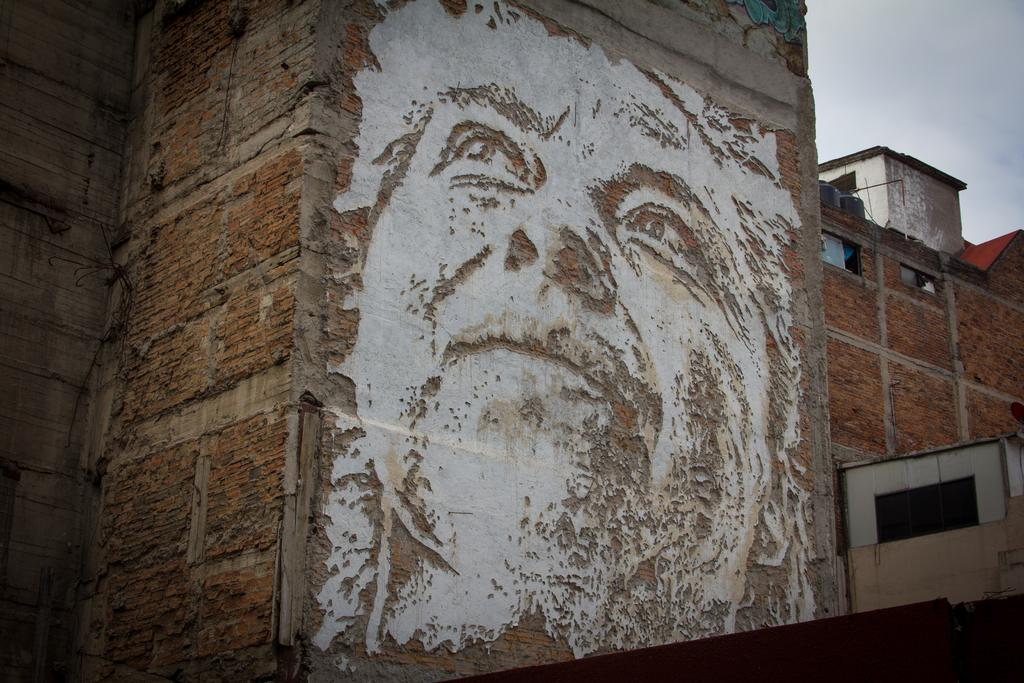What is depicted on the wall in the image? There is an image of a person's face on the wall. What type of structure can be seen in the image? There is a building in the image. What architectural feature is present in the building? There are windows in the image. What else can be seen in the image besides the building? There are objects in the image. What is visible in the background of the image? The sky is visible in the background of the image. What type of bone can be seen in the image? There is no bone present in the image. What type of mint is growing in the field in the image? There is no field or mint present in the image. 